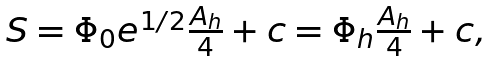<formula> <loc_0><loc_0><loc_500><loc_500>\begin{array} { c } S = \Phi _ { 0 } e ^ { 1 / 2 } \frac { A _ { h } } 4 + c = \Phi _ { h } \frac { A _ { h } } 4 + c , \end{array}</formula> 